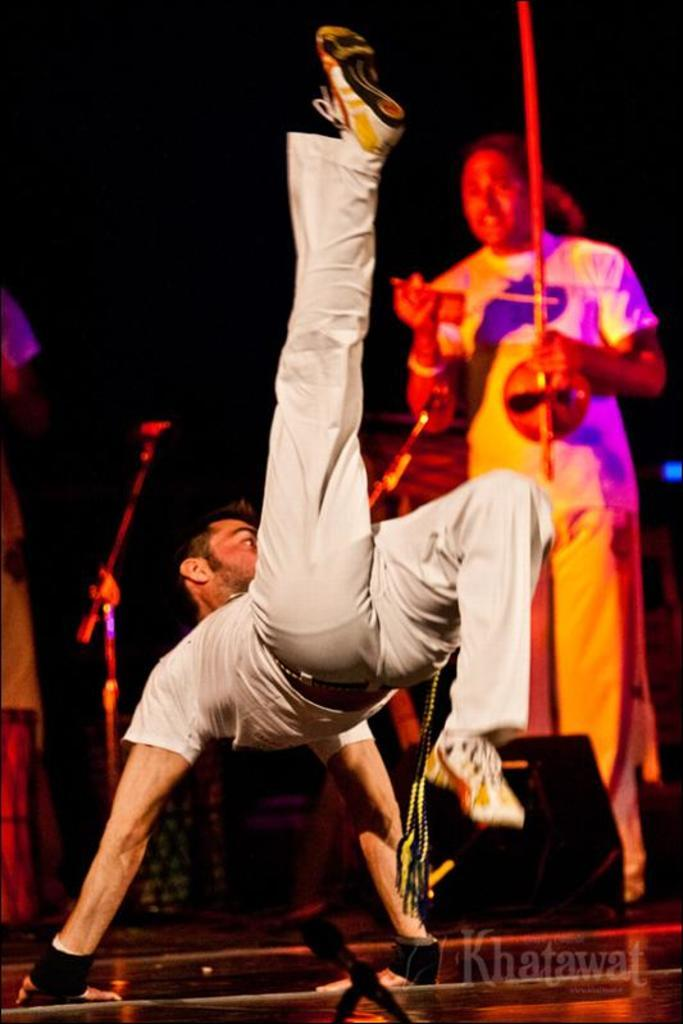Who is the main subject in the image? There is a boy in the image. What is the boy doing in the image? The boy is dancing. Is there anyone else in the image besides the boy? Yes, there is a person standing in the image. What can be observed about the background of the image? The background of the image is dark. What type of nerve is responsible for the boy's dancing in the image? There is no information about the boy's nervous system in the image, so we cannot determine which nerve is responsible for his dancing. 